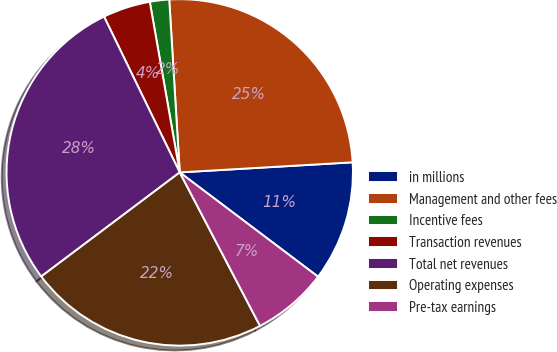Convert chart. <chart><loc_0><loc_0><loc_500><loc_500><pie_chart><fcel>in millions<fcel>Management and other fees<fcel>Incentive fees<fcel>Transaction revenues<fcel>Total net revenues<fcel>Operating expenses<fcel>Pre-tax earnings<nl><fcel>11.21%<fcel>25.04%<fcel>1.8%<fcel>4.43%<fcel>28.06%<fcel>22.41%<fcel>7.05%<nl></chart> 